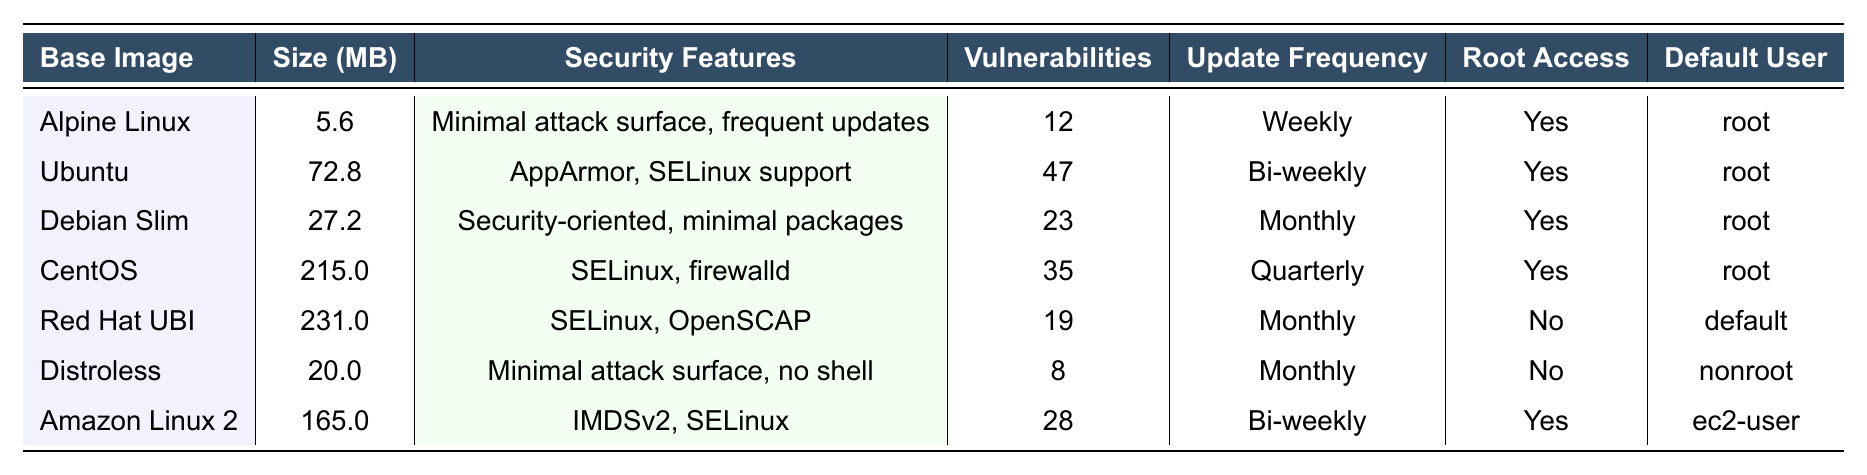What is the size of Alpine Linux? From the table, the size of Alpine Linux is directly listed under the "Size (MB)" column, which shows 5.6.
Answer: 5.6 MB Which base image has the fewest vulnerabilities in the last 12 months? By scanning the "Vulnerabilities" column, we see that Distroless has the lowest number of vulnerabilities at 8, while the others have higher counts.
Answer: Distroless Is Debian Slim's update frequency monthly? The table specifies the "Update Frequency" for Debian Slim, which is listed as "Monthly." Therefore, it confirms the statement.
Answer: Yes Which base image supports SELinux? We look through the "Security Features" column for the mention of SELinux. Both Ubuntu, CentOS, Red Hat UBI, and Amazon Linux 2 have SELinux listed as part of their security features.
Answer: Ubuntu, CentOS, Red Hat UBI, Amazon Linux 2 What is the combined size of Ubuntu and Amazon Linux 2? To find the combined size, we add the size of Ubuntu (72.8 MB) and Amazon Linux 2 (165.0 MB): 72.8 + 165.0 = 237.8 MB.
Answer: 237.8 MB Does the Red Hat Universal Base Image allow root access? The table indicates that the "Root Access" for Red Hat UBI is marked as "No," indicating that it does not allow root access.
Answer: No Which base image has the highest number of vulnerabilities? We check the "Vulnerabilities" column to identify the highest number: Ubuntu has 47, which is the highest compared to others.
Answer: Ubuntu Between Debian Slim and CentOS, which has a higher number of vulnerabilities? By comparing the "Vulnerabilities" values, Debian Slim has 23 while CentOS has 35. Since 35 is greater than 23, CentOS has the higher count.
Answer: CentOS What is the default user for Distroless? In the "Default User" column, it clearly states that the default user for Distroless is "nonroot."
Answer: nonroot Which base image has the largest size? Looking at the "Size (MB)" column, CentOS has the largest size listed at 215.0 MB compared to other images.
Answer: CentOS 